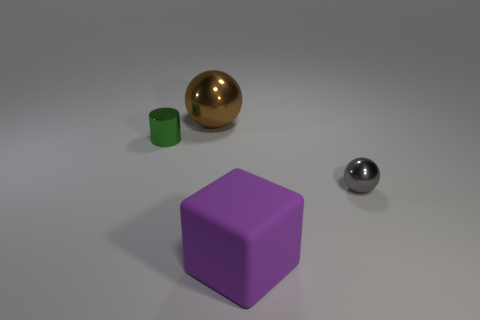Add 3 large green metal things. How many objects exist? 7 Subtract all cylinders. How many objects are left? 3 Subtract 1 purple blocks. How many objects are left? 3 Subtract all big spheres. Subtract all large brown rubber spheres. How many objects are left? 3 Add 1 large shiny spheres. How many large shiny spheres are left? 2 Add 1 large purple rubber objects. How many large purple rubber objects exist? 2 